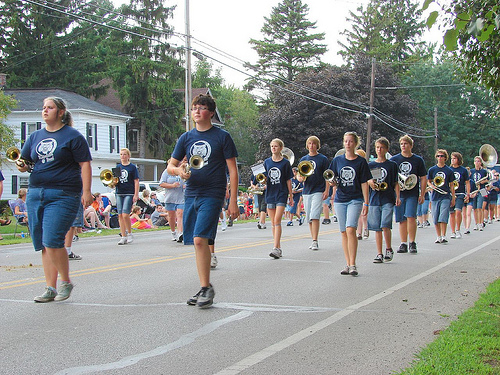<image>
Is there a house behind the road? Yes. From this viewpoint, the house is positioned behind the road, with the road partially or fully occluding the house. 